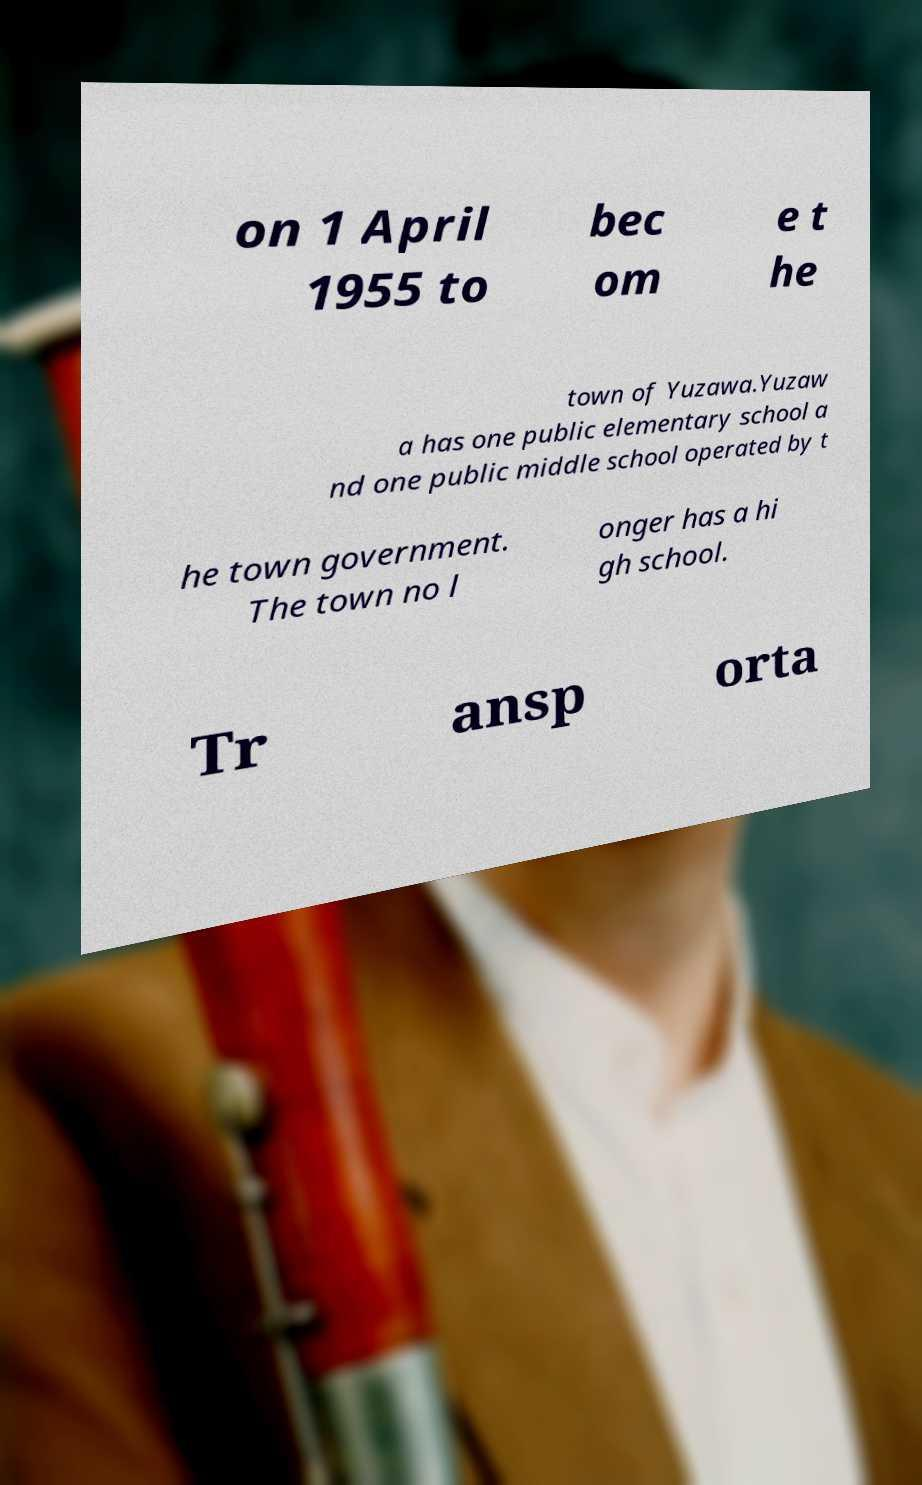What messages or text are displayed in this image? I need them in a readable, typed format. on 1 April 1955 to bec om e t he town of Yuzawa.Yuzaw a has one public elementary school a nd one public middle school operated by t he town government. The town no l onger has a hi gh school. Tr ansp orta 